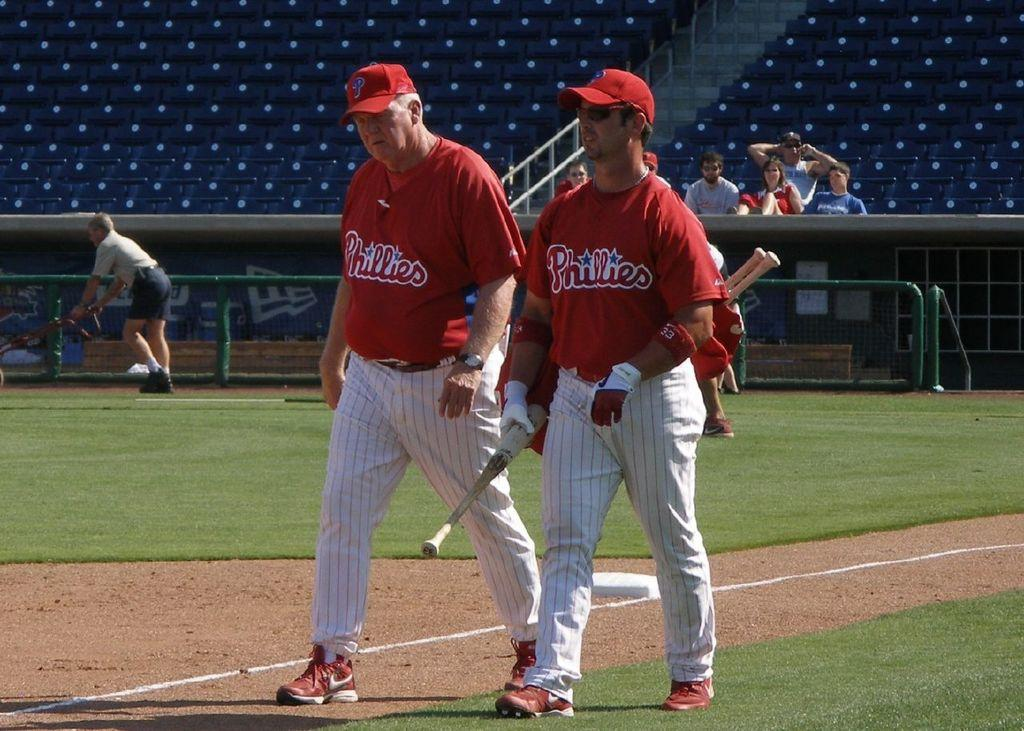Provide a one-sentence caption for the provided image. Two men, whose shirts read Phillies, stand on a baseball field. 